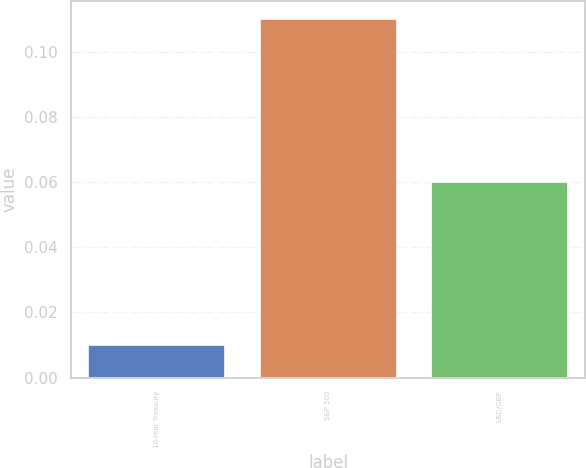Convert chart to OTSL. <chart><loc_0><loc_0><loc_500><loc_500><bar_chart><fcel>10-Year Treasury<fcel>S&P 500<fcel>USD/GBP<nl><fcel>0.01<fcel>0.11<fcel>0.06<nl></chart> 